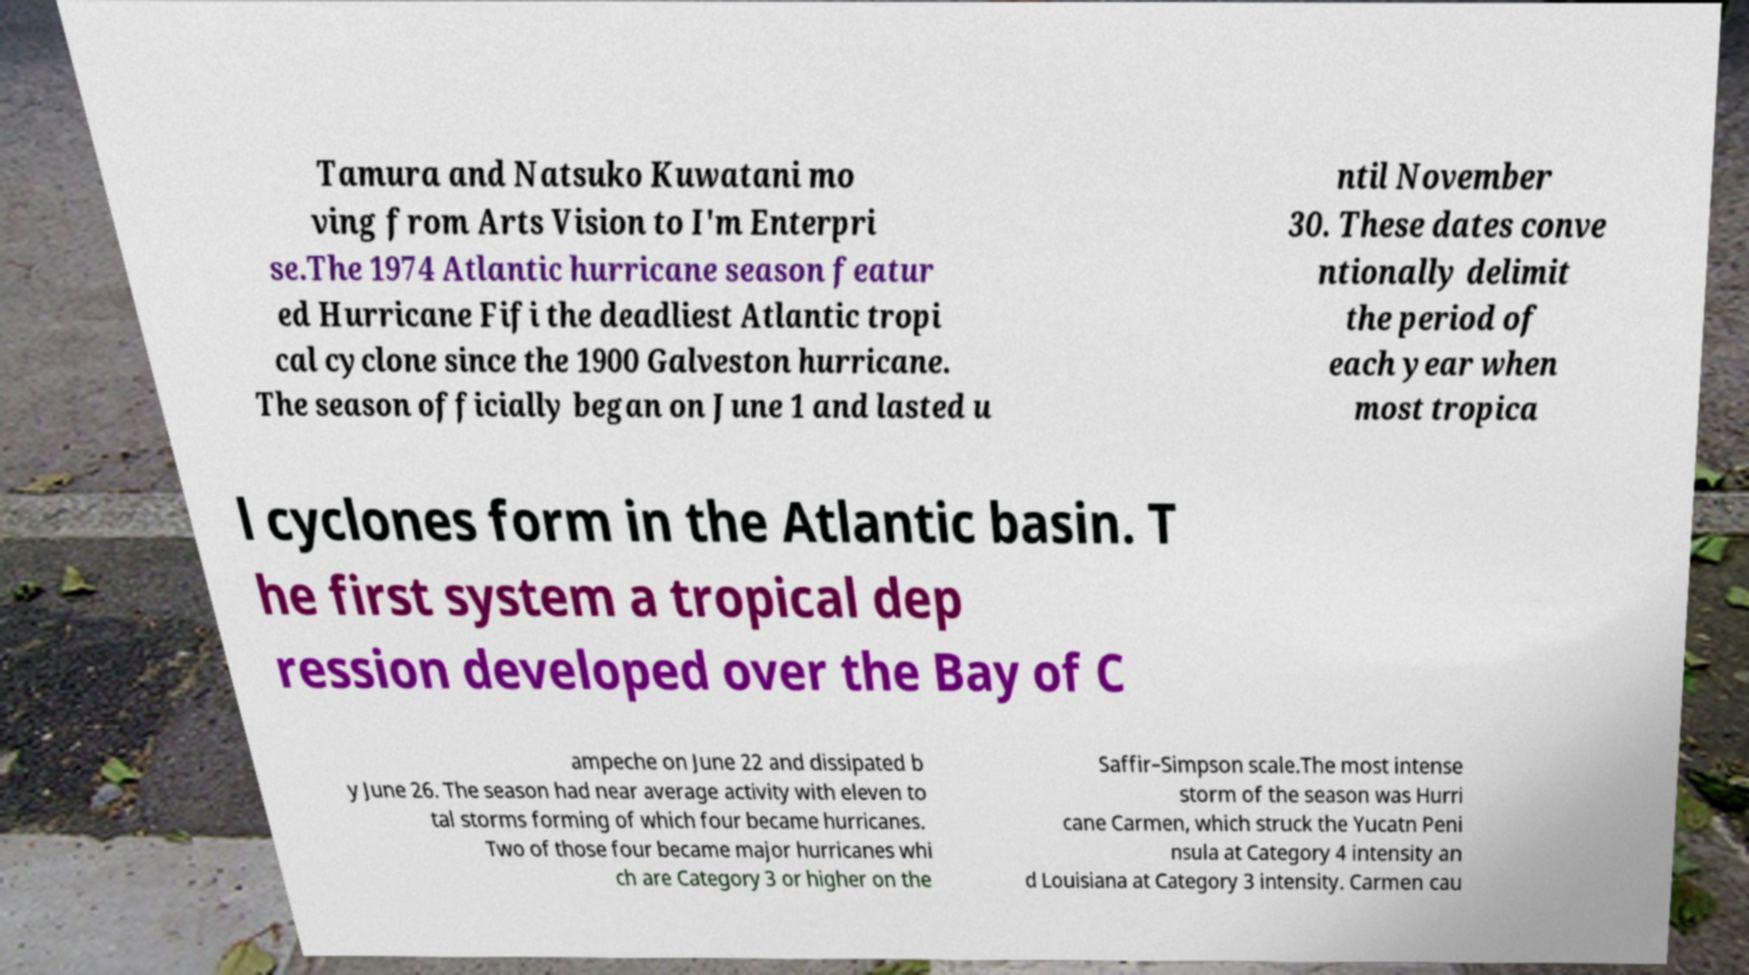Could you extract and type out the text from this image? Tamura and Natsuko Kuwatani mo ving from Arts Vision to I'm Enterpri se.The 1974 Atlantic hurricane season featur ed Hurricane Fifi the deadliest Atlantic tropi cal cyclone since the 1900 Galveston hurricane. The season officially began on June 1 and lasted u ntil November 30. These dates conve ntionally delimit the period of each year when most tropica l cyclones form in the Atlantic basin. T he first system a tropical dep ression developed over the Bay of C ampeche on June 22 and dissipated b y June 26. The season had near average activity with eleven to tal storms forming of which four became hurricanes. Two of those four became major hurricanes whi ch are Category 3 or higher on the Saffir–Simpson scale.The most intense storm of the season was Hurri cane Carmen, which struck the Yucatn Peni nsula at Category 4 intensity an d Louisiana at Category 3 intensity. Carmen cau 